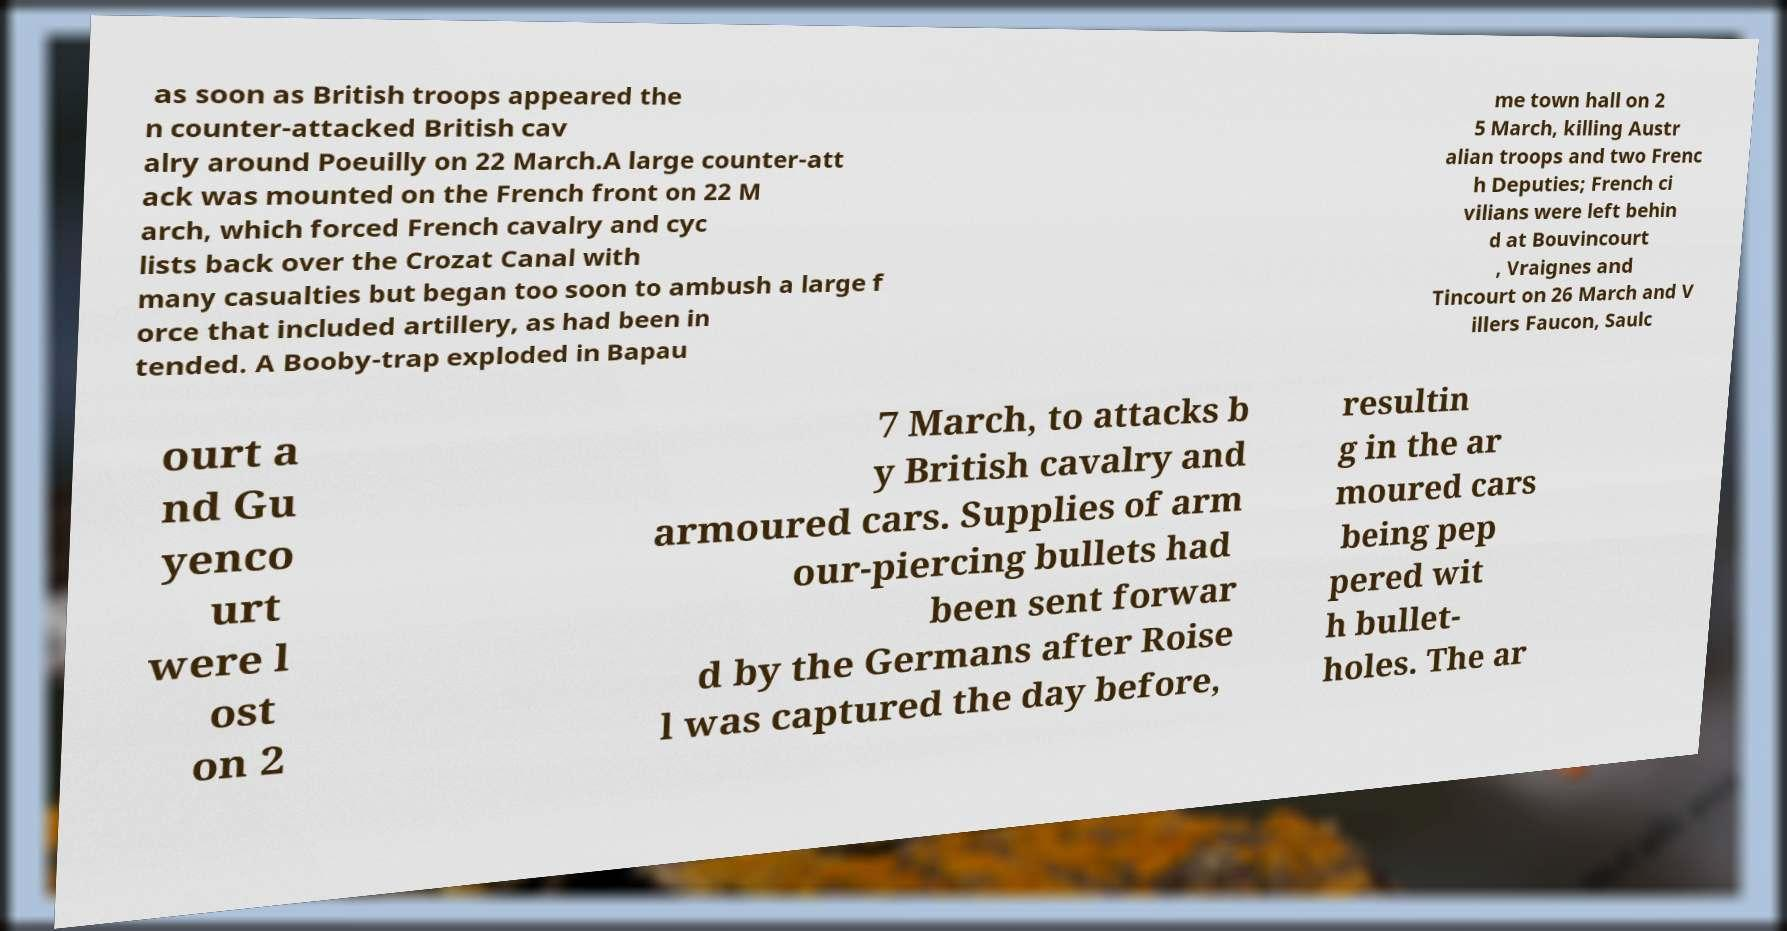For documentation purposes, I need the text within this image transcribed. Could you provide that? as soon as British troops appeared the n counter-attacked British cav alry around Poeuilly on 22 March.A large counter-att ack was mounted on the French front on 22 M arch, which forced French cavalry and cyc lists back over the Crozat Canal with many casualties but began too soon to ambush a large f orce that included artillery, as had been in tended. A Booby-trap exploded in Bapau me town hall on 2 5 March, killing Austr alian troops and two Frenc h Deputies; French ci vilians were left behin d at Bouvincourt , Vraignes and Tincourt on 26 March and V illers Faucon, Saulc ourt a nd Gu yenco urt were l ost on 2 7 March, to attacks b y British cavalry and armoured cars. Supplies of arm our-piercing bullets had been sent forwar d by the Germans after Roise l was captured the day before, resultin g in the ar moured cars being pep pered wit h bullet- holes. The ar 